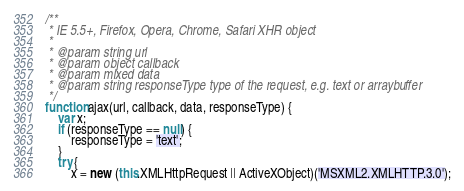<code> <loc_0><loc_0><loc_500><loc_500><_JavaScript_>/**
 * IE 5.5+, Firefox, Opera, Chrome, Safari XHR object
 *
 * @param string url
 * @param object callback
 * @param mixed data
 * @param string responseType type of the request, e.g. text or arraybuffer
 */
function ajax(url, callback, data, responseType) {
    var x;
    if (responseType == null) {
        responseType = 'text';
    }
    try {
        x = new (this.XMLHttpRequest || ActiveXObject)('MSXML2.XMLHTTP.3.0');</code> 